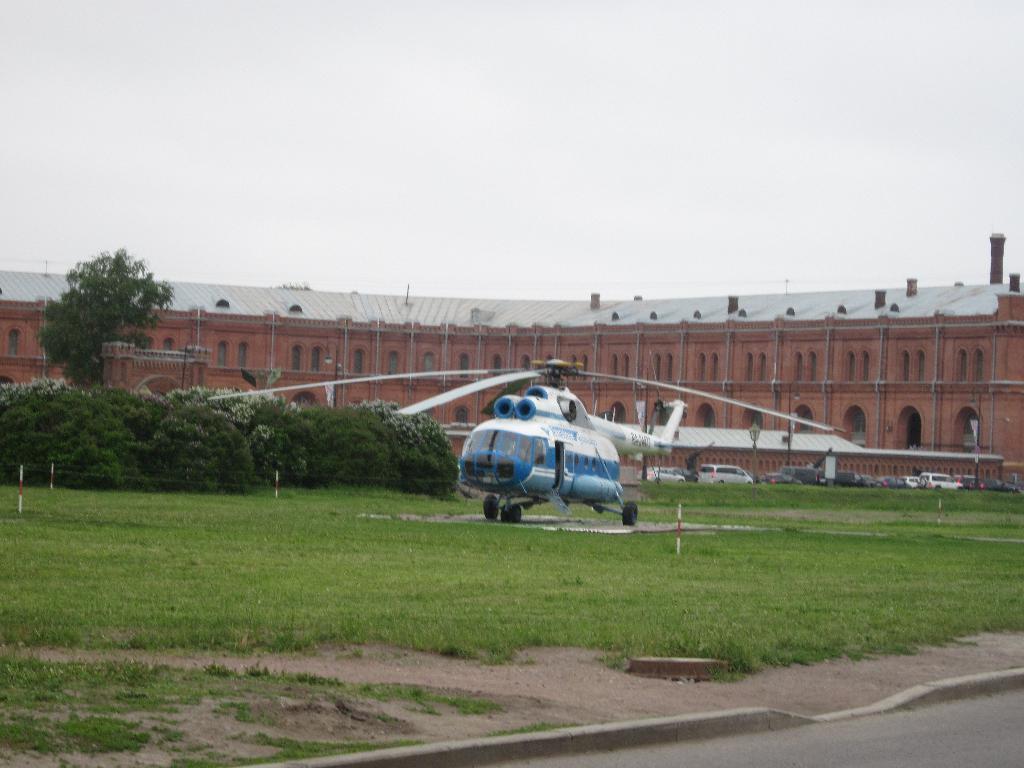Describe this image in one or two sentences. In this image we can see buildings, trees, bushes, ground, road, cars and a helicopter. 